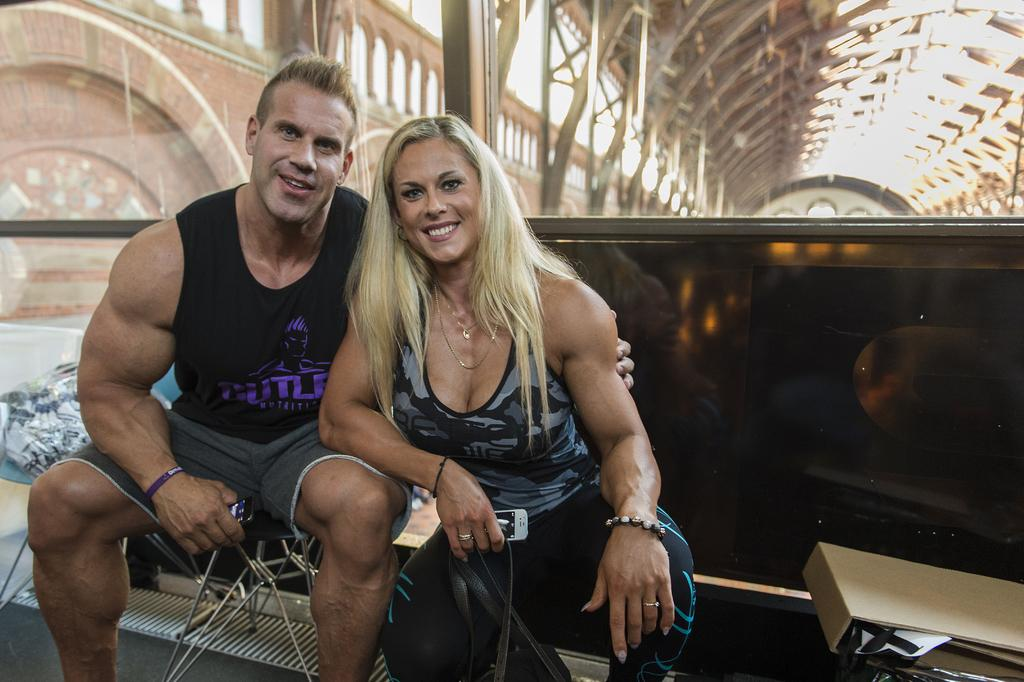Who is present in the image? There is a man and a woman in the image. What expressions do the man and woman have? Both the man and the woman are smiling. What can be seen in the background of the image? There appears to be a railing in the background of the image. Where is the file located in the image? The file is on the right side bottom of the image. How does the kitten create friction while walking on the railing in the image? There is no kitten present in the image, and therefore no such activity can be observed. 